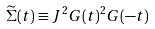Convert formula to latex. <formula><loc_0><loc_0><loc_500><loc_500>\widetilde { \Sigma } ( t ) \equiv J ^ { 2 } G ( t ) ^ { 2 } G ( - t )</formula> 